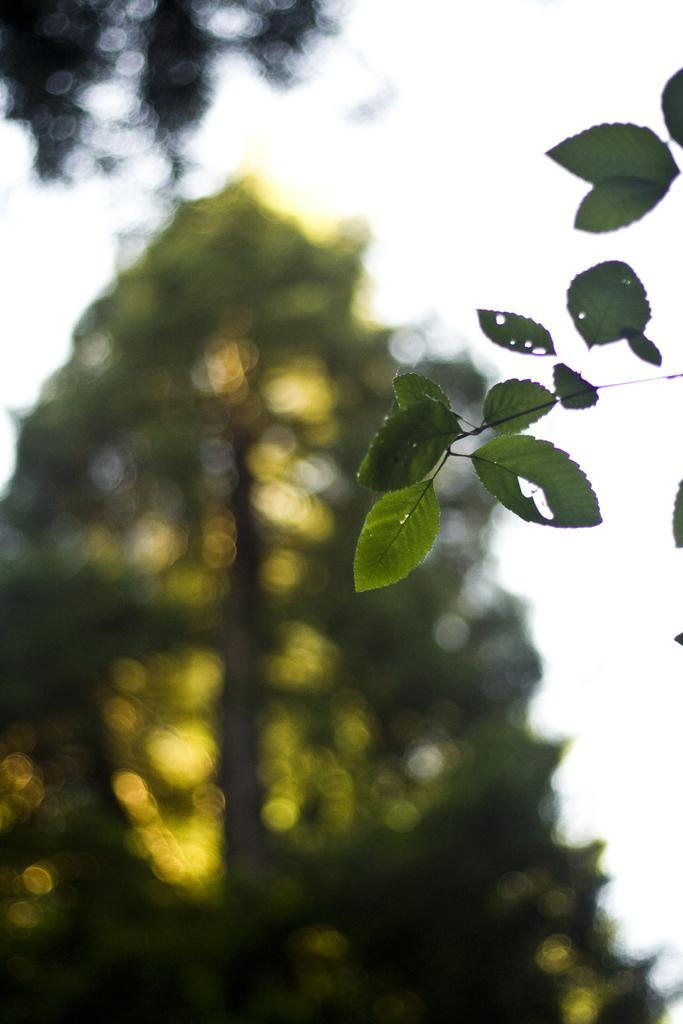Can you describe this image briefly? In this picture I can see leaves, and in the background there are trees and the sky. 